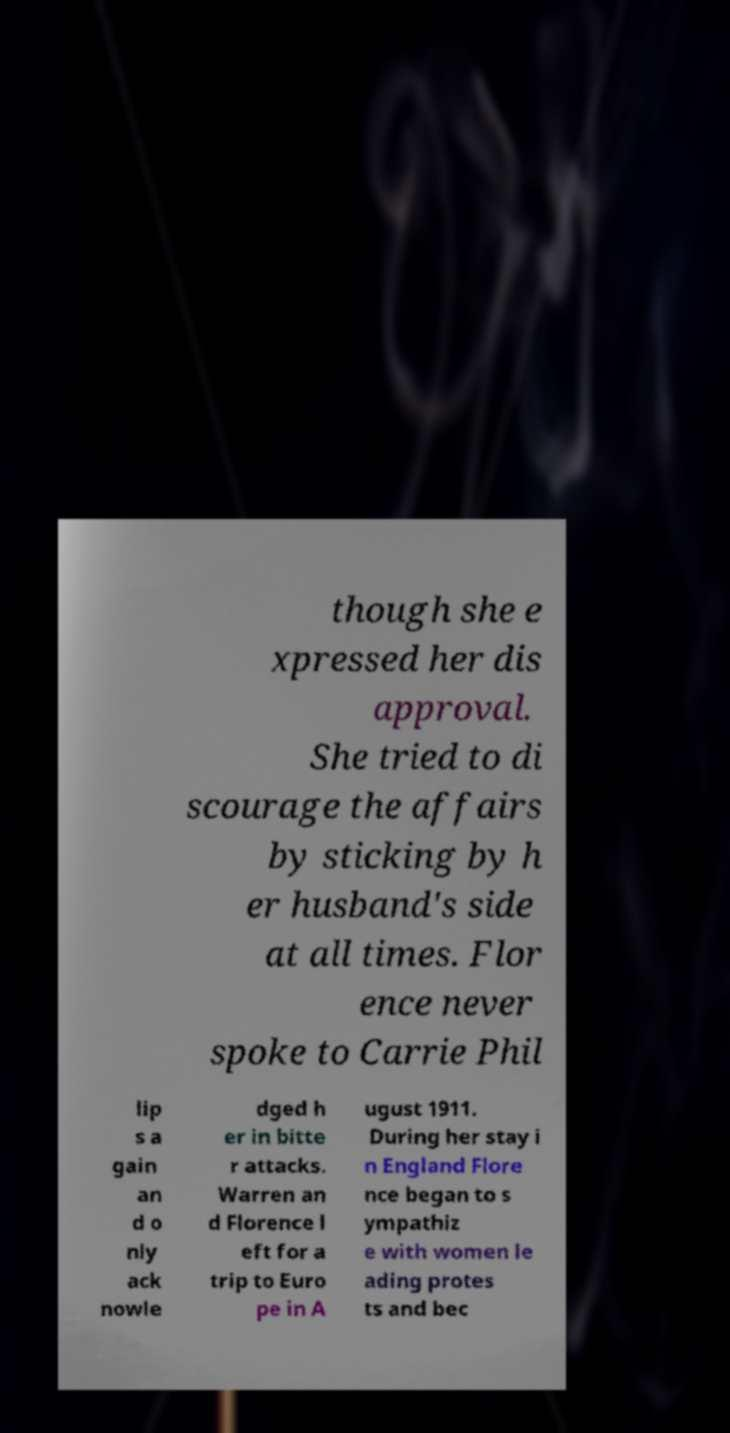For documentation purposes, I need the text within this image transcribed. Could you provide that? though she e xpressed her dis approval. She tried to di scourage the affairs by sticking by h er husband's side at all times. Flor ence never spoke to Carrie Phil lip s a gain an d o nly ack nowle dged h er in bitte r attacks. Warren an d Florence l eft for a trip to Euro pe in A ugust 1911. During her stay i n England Flore nce began to s ympathiz e with women le ading protes ts and bec 